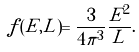Convert formula to latex. <formula><loc_0><loc_0><loc_500><loc_500>f ( E , L ) = \frac { 3 } { 4 \pi ^ { 3 } } \frac { E ^ { 2 } } { L } .</formula> 